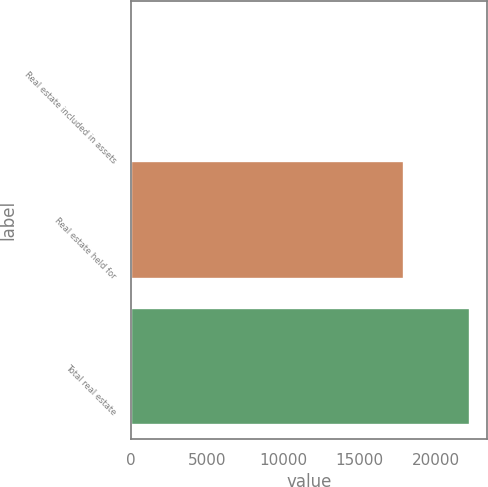Convert chart to OTSL. <chart><loc_0><loc_0><loc_500><loc_500><bar_chart><fcel>Real estate included in assets<fcel>Real estate held for<fcel>Total real estate<nl><fcel>109<fcel>17916<fcel>22269<nl></chart> 